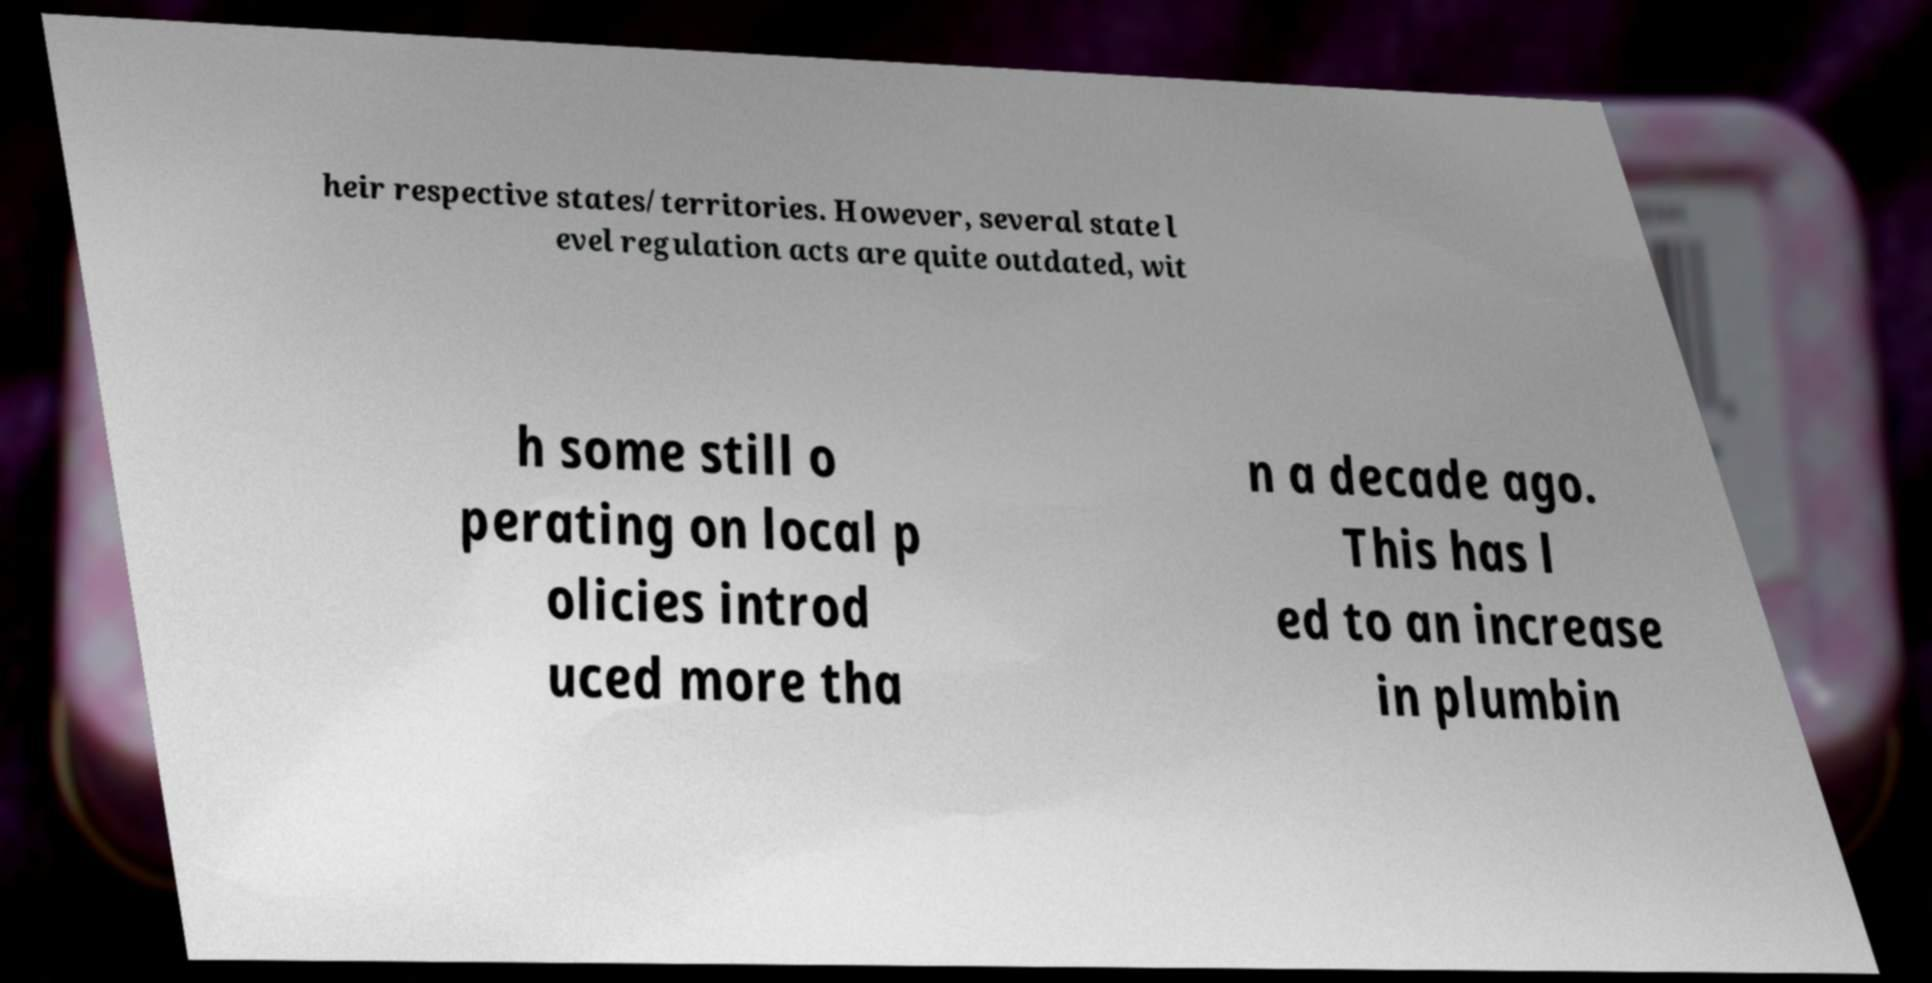For documentation purposes, I need the text within this image transcribed. Could you provide that? heir respective states/territories. However, several state l evel regulation acts are quite outdated, wit h some still o perating on local p olicies introd uced more tha n a decade ago. This has l ed to an increase in plumbin 